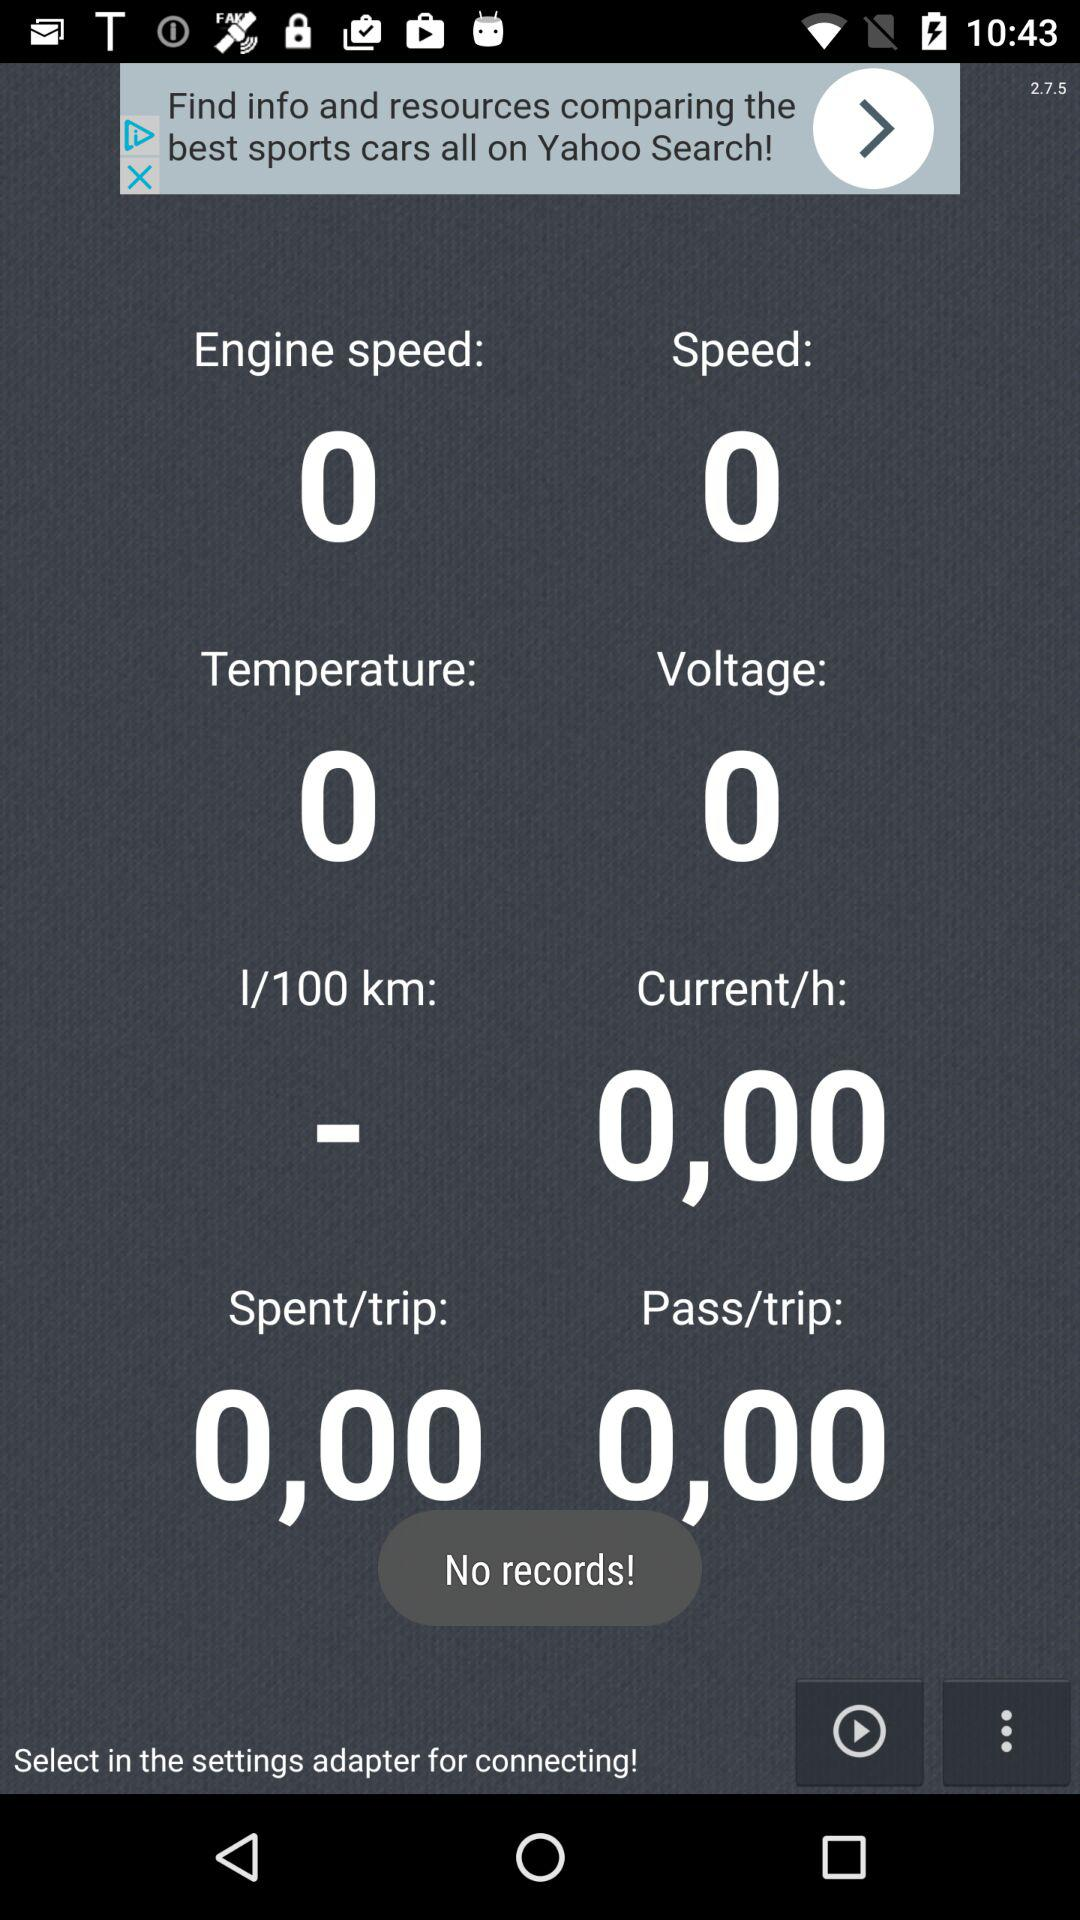What is the engine speed? The engine speed is 0. 